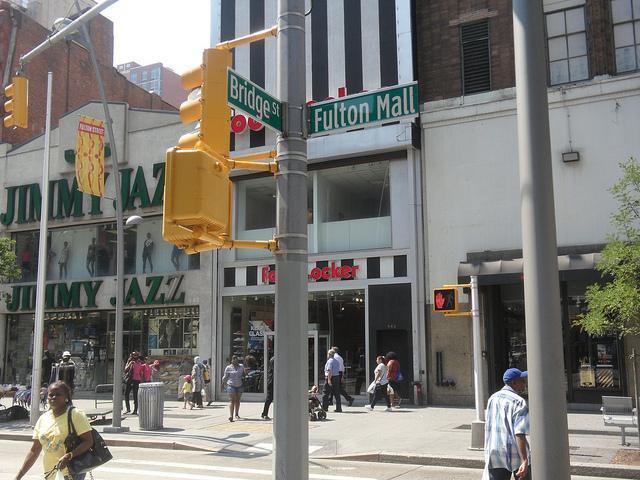Where should you go from the traffic light if you want to go to Fulton Mall?
Indicate the correct response by choosing from the four available options to answer the question.
Options: Go back, turn left, go straight, turn right. Turn right. 